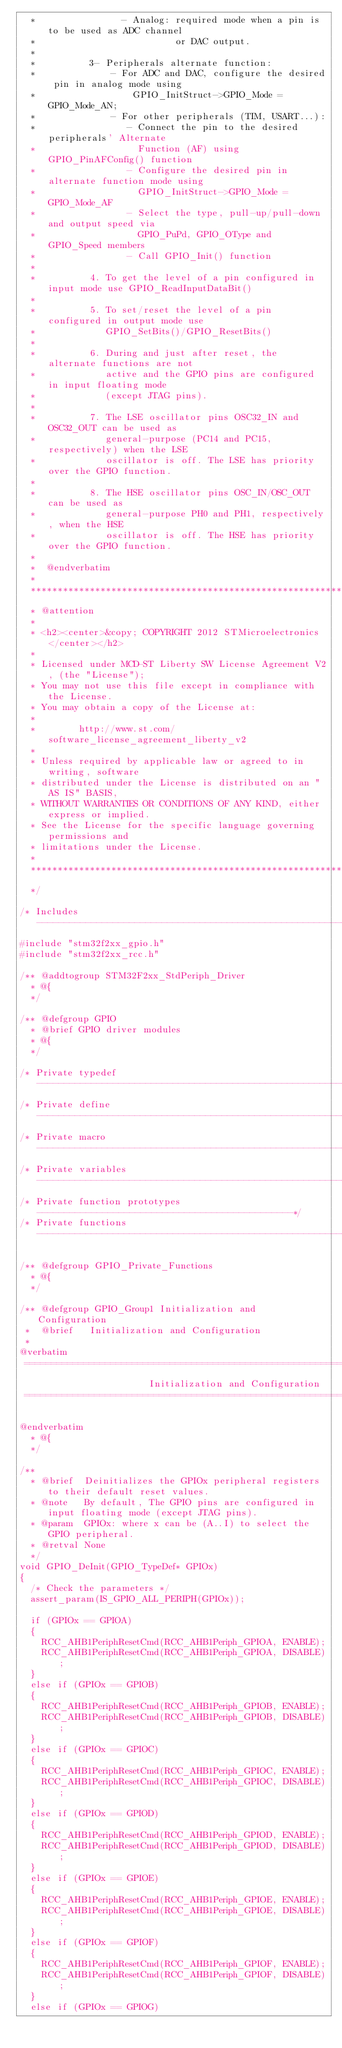Convert code to text. <code><loc_0><loc_0><loc_500><loc_500><_C_>  *                - Analog: required mode when a pin is to be used as ADC channel
  *                          or DAC output.
  *
  *          3- Peripherals alternate function:
  *              - For ADC and DAC, configure the desired pin in analog mode using
  *                  GPIO_InitStruct->GPIO_Mode = GPIO_Mode_AN;
  *              - For other peripherals (TIM, USART...):
  *                 - Connect the pin to the desired peripherals' Alternate
  *                   Function (AF) using GPIO_PinAFConfig() function
  *                 - Configure the desired pin in alternate function mode using
  *                   GPIO_InitStruct->GPIO_Mode = GPIO_Mode_AF
  *                 - Select the type, pull-up/pull-down and output speed via
  *                   GPIO_PuPd, GPIO_OType and GPIO_Speed members
  *                 - Call GPIO_Init() function
  *
  *          4. To get the level of a pin configured in input mode use GPIO_ReadInputDataBit()
  *
  *          5. To set/reset the level of a pin configured in output mode use
  *             GPIO_SetBits()/GPIO_ResetBits()
  *
  *          6. During and just after reset, the alternate functions are not
  *             active and the GPIO pins are configured in input floating mode
  *             (except JTAG pins).
  *
  *          7. The LSE oscillator pins OSC32_IN and OSC32_OUT can be used as
  *             general-purpose (PC14 and PC15, respectively) when the LSE
  *             oscillator is off. The LSE has priority over the GPIO function.
  *
  *          8. The HSE oscillator pins OSC_IN/OSC_OUT can be used as
  *             general-purpose PH0 and PH1, respectively, when the HSE
  *             oscillator is off. The HSE has priority over the GPIO function.
  *
  *  @endverbatim
  *
  ******************************************************************************
  * @attention
  *
  * <h2><center>&copy; COPYRIGHT 2012 STMicroelectronics</center></h2>
  *
  * Licensed under MCD-ST Liberty SW License Agreement V2, (the "License");
  * You may not use this file except in compliance with the License.
  * You may obtain a copy of the License at:
  *
  *        http://www.st.com/software_license_agreement_liberty_v2
  *
  * Unless required by applicable law or agreed to in writing, software
  * distributed under the License is distributed on an "AS IS" BASIS,
  * WITHOUT WARRANTIES OR CONDITIONS OF ANY KIND, either express or implied.
  * See the License for the specific language governing permissions and
  * limitations under the License.
  *
  ******************************************************************************
  */

/* Includes ------------------------------------------------------------------*/
#include "stm32f2xx_gpio.h"
#include "stm32f2xx_rcc.h"

/** @addtogroup STM32F2xx_StdPeriph_Driver
  * @{
  */

/** @defgroup GPIO
  * @brief GPIO driver modules
  * @{
  */

/* Private typedef -----------------------------------------------------------*/
/* Private define ------------------------------------------------------------*/
/* Private macro -------------------------------------------------------------*/
/* Private variables ---------------------------------------------------------*/
/* Private function prototypes -----------------------------------------------*/
/* Private functions ---------------------------------------------------------*/

/** @defgroup GPIO_Private_Functions
  * @{
  */

/** @defgroup GPIO_Group1 Initialization and Configuration
 *  @brief   Initialization and Configuration
 *
@verbatim
 ===============================================================================
                        Initialization and Configuration
 ===============================================================================

@endverbatim
  * @{
  */

/**
  * @brief  Deinitializes the GPIOx peripheral registers to their default reset values.
  * @note   By default, The GPIO pins are configured in input floating mode (except JTAG pins).
  * @param  GPIOx: where x can be (A..I) to select the GPIO peripheral.
  * @retval None
  */
void GPIO_DeInit(GPIO_TypeDef* GPIOx)
{
  /* Check the parameters */
  assert_param(IS_GPIO_ALL_PERIPH(GPIOx));

  if (GPIOx == GPIOA)
  {
    RCC_AHB1PeriphResetCmd(RCC_AHB1Periph_GPIOA, ENABLE);
    RCC_AHB1PeriphResetCmd(RCC_AHB1Periph_GPIOA, DISABLE);
  }
  else if (GPIOx == GPIOB)
  {
    RCC_AHB1PeriphResetCmd(RCC_AHB1Periph_GPIOB, ENABLE);
    RCC_AHB1PeriphResetCmd(RCC_AHB1Periph_GPIOB, DISABLE);
  }
  else if (GPIOx == GPIOC)
  {
    RCC_AHB1PeriphResetCmd(RCC_AHB1Periph_GPIOC, ENABLE);
    RCC_AHB1PeriphResetCmd(RCC_AHB1Periph_GPIOC, DISABLE);
  }
  else if (GPIOx == GPIOD)
  {
    RCC_AHB1PeriphResetCmd(RCC_AHB1Periph_GPIOD, ENABLE);
    RCC_AHB1PeriphResetCmd(RCC_AHB1Periph_GPIOD, DISABLE);
  }
  else if (GPIOx == GPIOE)
  {
    RCC_AHB1PeriphResetCmd(RCC_AHB1Periph_GPIOE, ENABLE);
    RCC_AHB1PeriphResetCmd(RCC_AHB1Periph_GPIOE, DISABLE);
  }
  else if (GPIOx == GPIOF)
  {
    RCC_AHB1PeriphResetCmd(RCC_AHB1Periph_GPIOF, ENABLE);
    RCC_AHB1PeriphResetCmd(RCC_AHB1Periph_GPIOF, DISABLE);
  }
  else if (GPIOx == GPIOG)</code> 